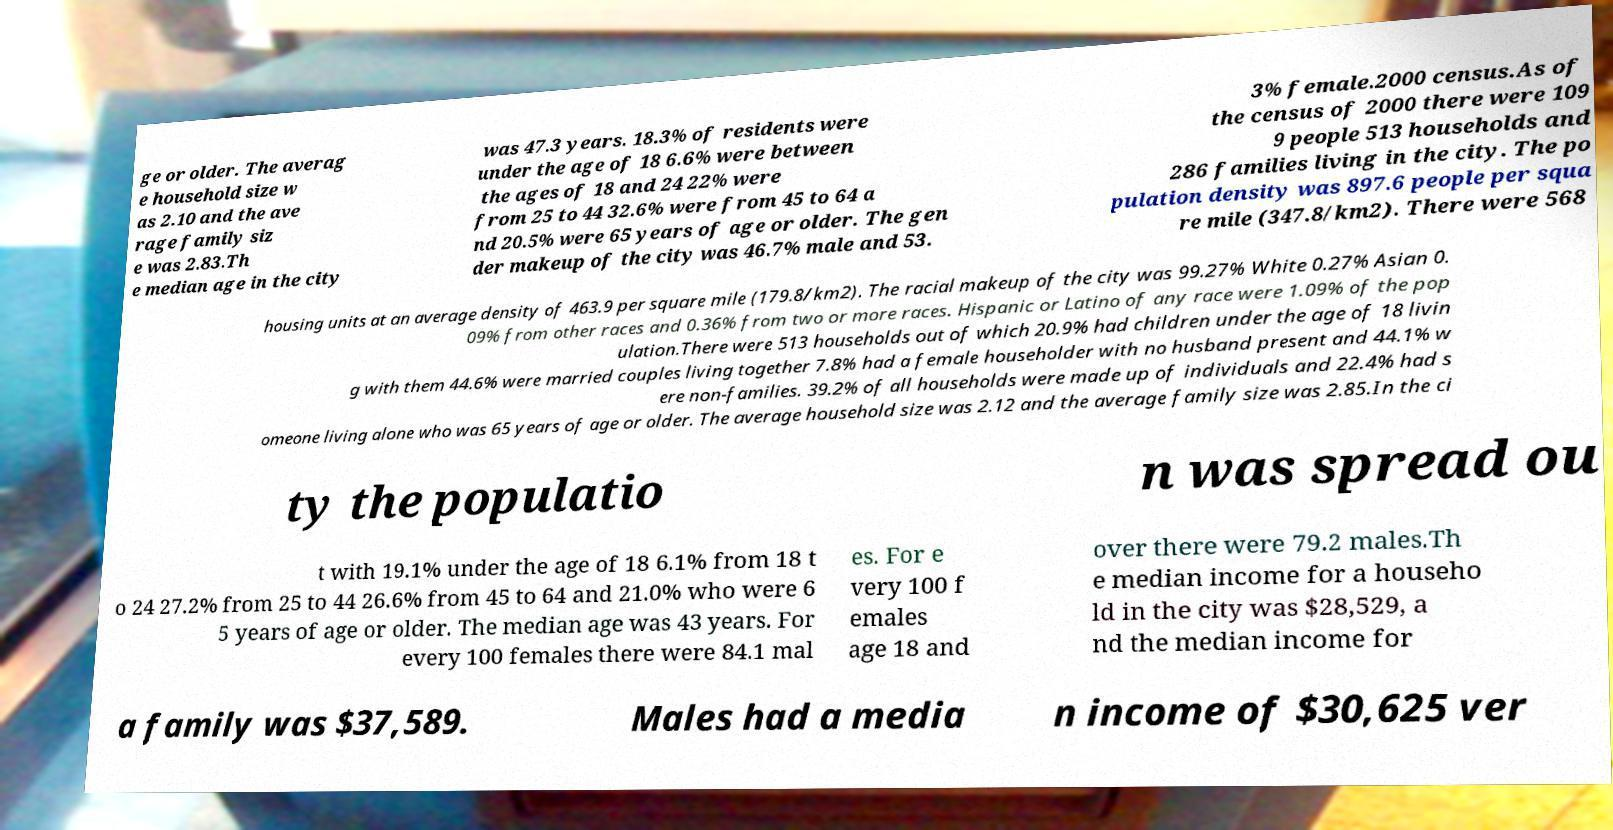Please identify and transcribe the text found in this image. ge or older. The averag e household size w as 2.10 and the ave rage family siz e was 2.83.Th e median age in the city was 47.3 years. 18.3% of residents were under the age of 18 6.6% were between the ages of 18 and 24 22% were from 25 to 44 32.6% were from 45 to 64 a nd 20.5% were 65 years of age or older. The gen der makeup of the city was 46.7% male and 53. 3% female.2000 census.As of the census of 2000 there were 109 9 people 513 households and 286 families living in the city. The po pulation density was 897.6 people per squa re mile (347.8/km2). There were 568 housing units at an average density of 463.9 per square mile (179.8/km2). The racial makeup of the city was 99.27% White 0.27% Asian 0. 09% from other races and 0.36% from two or more races. Hispanic or Latino of any race were 1.09% of the pop ulation.There were 513 households out of which 20.9% had children under the age of 18 livin g with them 44.6% were married couples living together 7.8% had a female householder with no husband present and 44.1% w ere non-families. 39.2% of all households were made up of individuals and 22.4% had s omeone living alone who was 65 years of age or older. The average household size was 2.12 and the average family size was 2.85.In the ci ty the populatio n was spread ou t with 19.1% under the age of 18 6.1% from 18 t o 24 27.2% from 25 to 44 26.6% from 45 to 64 and 21.0% who were 6 5 years of age or older. The median age was 43 years. For every 100 females there were 84.1 mal es. For e very 100 f emales age 18 and over there were 79.2 males.Th e median income for a househo ld in the city was $28,529, a nd the median income for a family was $37,589. Males had a media n income of $30,625 ver 